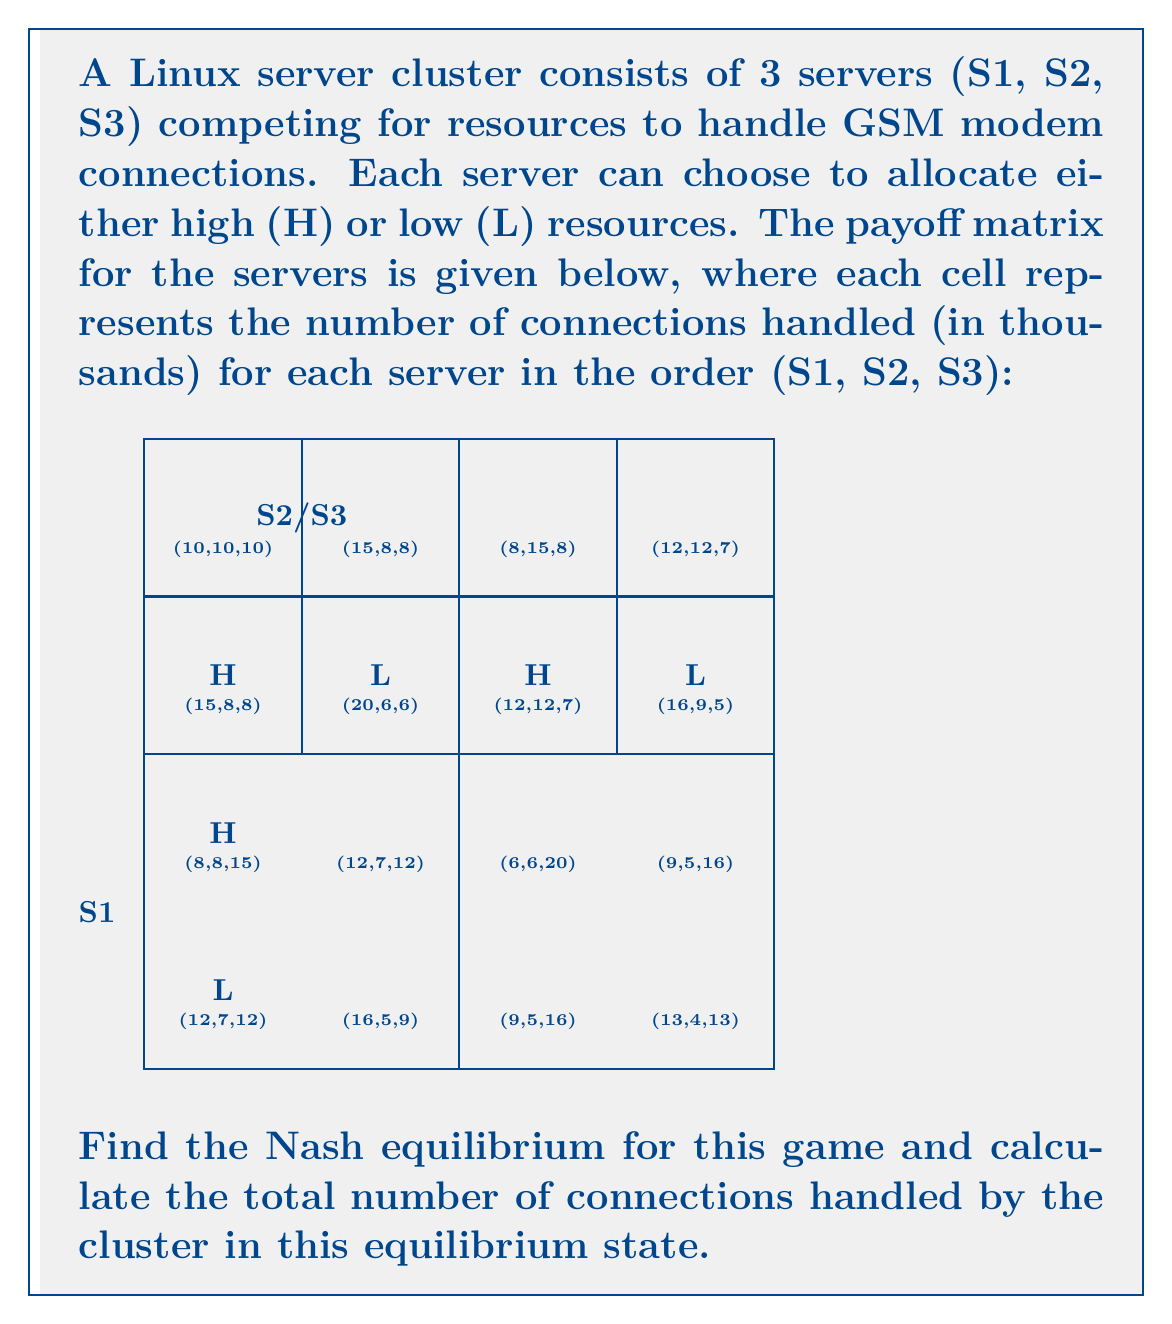Solve this math problem. To find the Nash equilibrium, we need to analyze each server's best response to the other servers' strategies:

1. First, let's consider S1's best responses:
   - If S2 and S3 both choose H: S1's best response is H (15 > 10)
   - If S2 chooses H and S3 chooses L: S1's best response is H (12 > 8)
   - If S2 chooses L and S3 chooses H: S1's best response is H (15 > 8)
   - If S2 and S3 both choose L: S1's best response is H (16 > 13)

2. Now, let's consider S2's best responses:
   - If S1 and S3 both choose H: S2's best response is H (10 > 8)
   - If S1 chooses H and S3 chooses L: S2's best response is H (12 > 9)
   - If S1 chooses L and S3 chooses H: S2's best response is H (15 > 12)
   - If S1 and S3 both choose L: S2's best response is H (9 > 4)

3. Finally, let's consider S3's best responses:
   - If S1 and S2 both choose H: S3's best response is H (10 > 8)
   - If S1 chooses H and S2 chooses L: S3's best response is H (12 > 7)
   - If S1 chooses L and S2 chooses H: S3's best response is H (15 > 12)
   - If S1 and S2 both choose L: S3's best response is H (16 > 13)

From this analysis, we can see that regardless of what the other servers do, each server's best strategy is always to choose H (high resources). Therefore, the Nash equilibrium is (H, H, H).

In this equilibrium state, each server handles 10,000 connections, as shown in the payoff matrix cell (10, 10, 10) when all servers choose H.

To calculate the total number of connections handled by the cluster:

$$ \text{Total connections} = 10,000 + 10,000 + 10,000 = 30,000 $$
Answer: Nash equilibrium: (H, H, H); Total connections: 30,000 